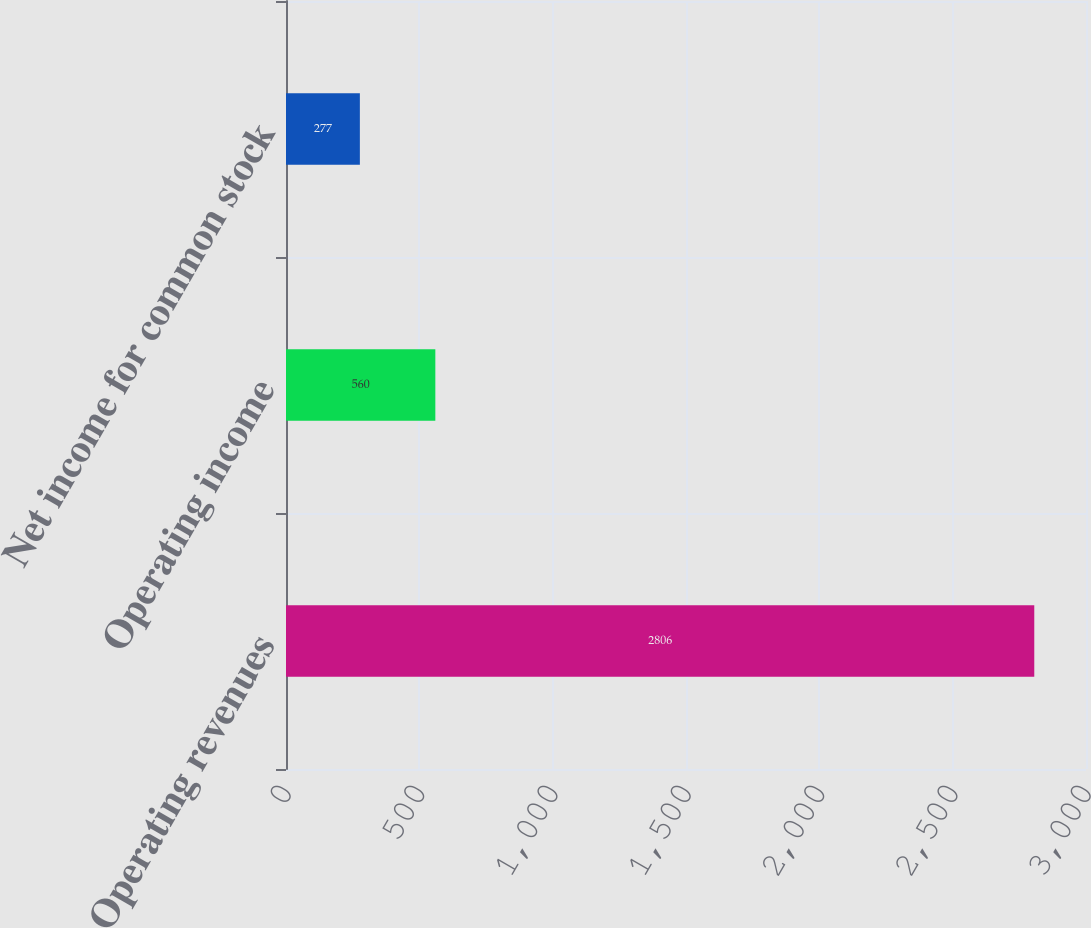Convert chart. <chart><loc_0><loc_0><loc_500><loc_500><bar_chart><fcel>Operating revenues<fcel>Operating income<fcel>Net income for common stock<nl><fcel>2806<fcel>560<fcel>277<nl></chart> 